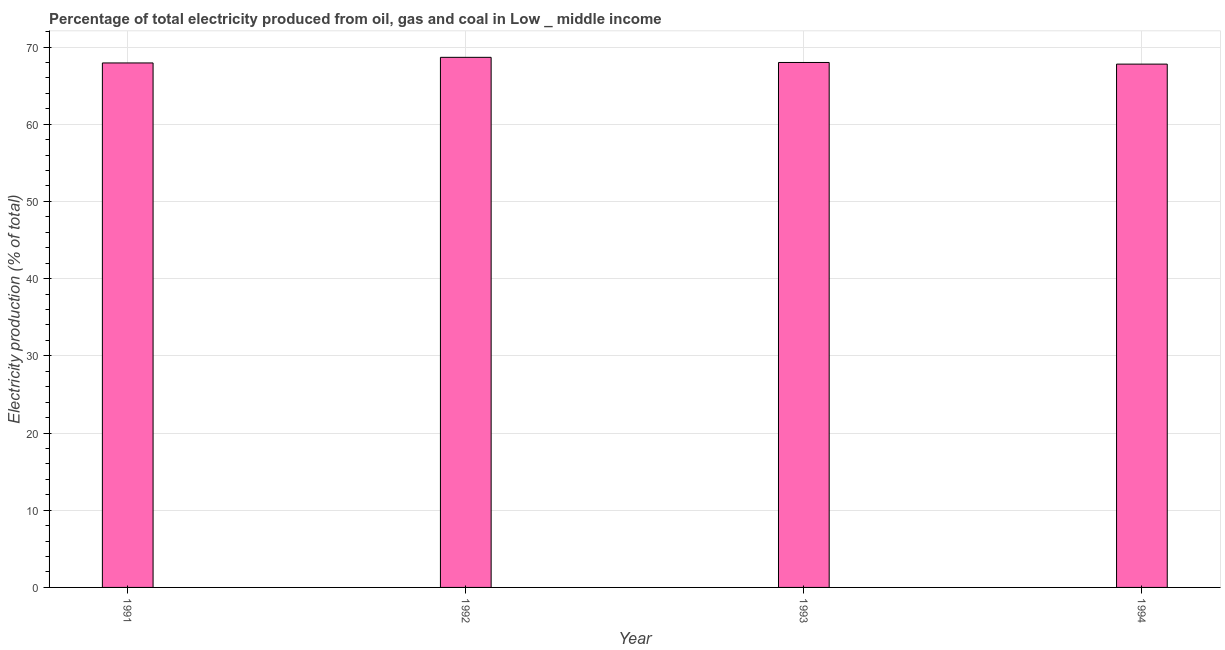What is the title of the graph?
Your answer should be compact. Percentage of total electricity produced from oil, gas and coal in Low _ middle income. What is the label or title of the Y-axis?
Make the answer very short. Electricity production (% of total). What is the electricity production in 1994?
Make the answer very short. 67.78. Across all years, what is the maximum electricity production?
Give a very brief answer. 68.66. Across all years, what is the minimum electricity production?
Your response must be concise. 67.78. What is the sum of the electricity production?
Make the answer very short. 272.38. What is the average electricity production per year?
Your answer should be very brief. 68.09. What is the median electricity production?
Your answer should be compact. 67.97. Is the difference between the electricity production in 1991 and 1994 greater than the difference between any two years?
Keep it short and to the point. No. What is the difference between the highest and the second highest electricity production?
Make the answer very short. 0.67. Is the sum of the electricity production in 1991 and 1993 greater than the maximum electricity production across all years?
Offer a terse response. Yes. In how many years, is the electricity production greater than the average electricity production taken over all years?
Offer a terse response. 1. Are all the bars in the graph horizontal?
Provide a short and direct response. No. How many years are there in the graph?
Your answer should be very brief. 4. Are the values on the major ticks of Y-axis written in scientific E-notation?
Provide a succinct answer. No. What is the Electricity production (% of total) in 1991?
Your response must be concise. 67.93. What is the Electricity production (% of total) in 1992?
Provide a short and direct response. 68.66. What is the Electricity production (% of total) of 1993?
Make the answer very short. 68. What is the Electricity production (% of total) of 1994?
Ensure brevity in your answer.  67.78. What is the difference between the Electricity production (% of total) in 1991 and 1992?
Make the answer very short. -0.73. What is the difference between the Electricity production (% of total) in 1991 and 1993?
Give a very brief answer. -0.06. What is the difference between the Electricity production (% of total) in 1991 and 1994?
Your response must be concise. 0.15. What is the difference between the Electricity production (% of total) in 1992 and 1993?
Give a very brief answer. 0.67. What is the difference between the Electricity production (% of total) in 1992 and 1994?
Keep it short and to the point. 0.88. What is the difference between the Electricity production (% of total) in 1993 and 1994?
Give a very brief answer. 0.21. What is the ratio of the Electricity production (% of total) in 1991 to that in 1992?
Your answer should be very brief. 0.99. What is the ratio of the Electricity production (% of total) in 1991 to that in 1993?
Provide a short and direct response. 1. What is the ratio of the Electricity production (% of total) in 1993 to that in 1994?
Keep it short and to the point. 1. 